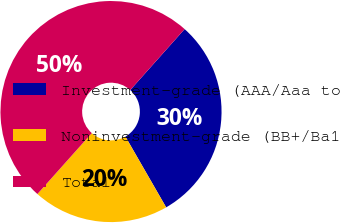Convert chart to OTSL. <chart><loc_0><loc_0><loc_500><loc_500><pie_chart><fcel>Investment-grade (AAA/Aaa to<fcel>Noninvestment-grade (BB+/Ba1<fcel>Total<nl><fcel>30.09%<fcel>19.91%<fcel>50.0%<nl></chart> 